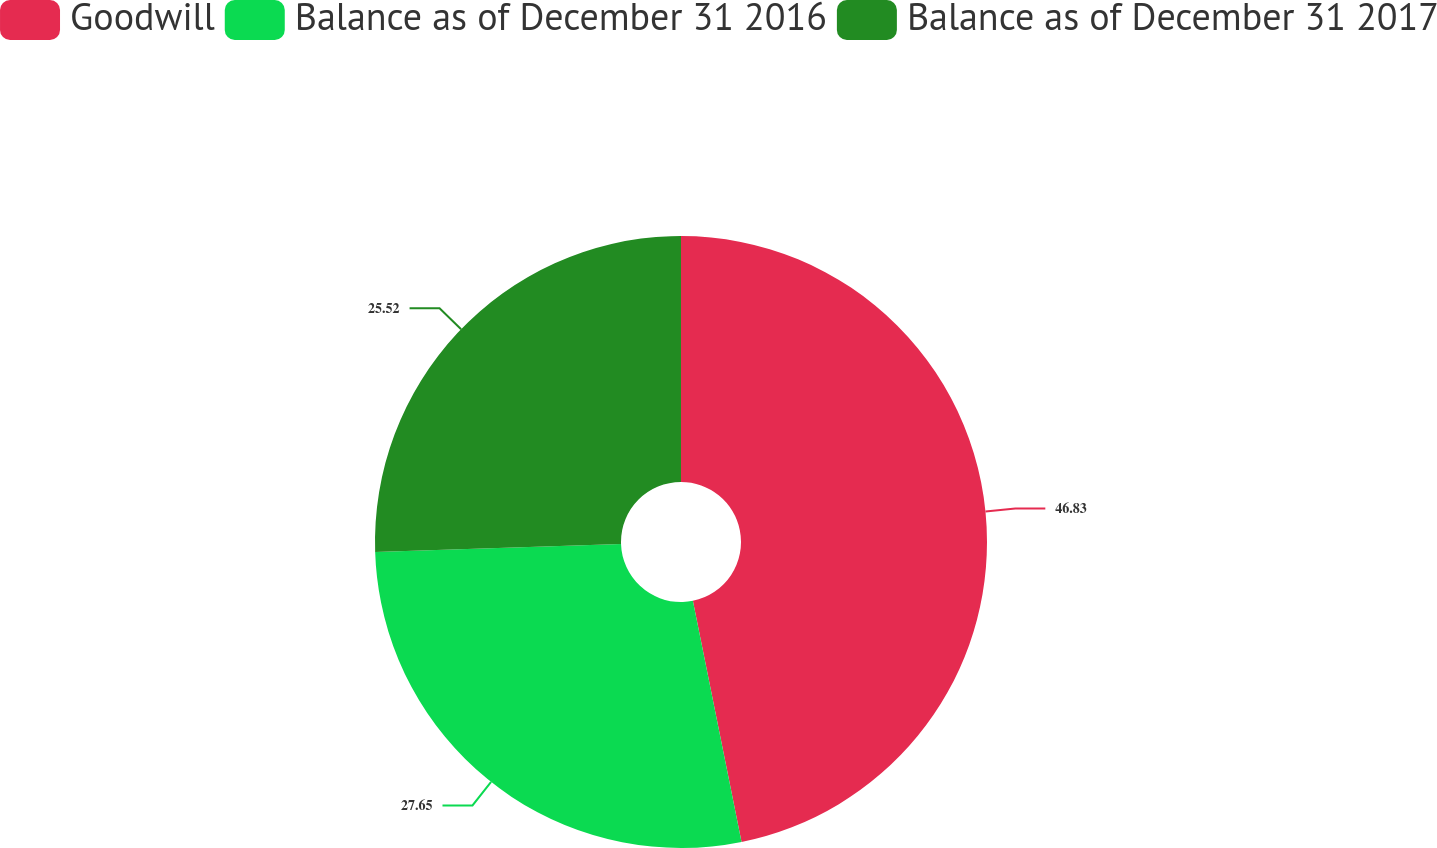<chart> <loc_0><loc_0><loc_500><loc_500><pie_chart><fcel>Goodwill<fcel>Balance as of December 31 2016<fcel>Balance as of December 31 2017<nl><fcel>46.83%<fcel>27.65%<fcel>25.52%<nl></chart> 